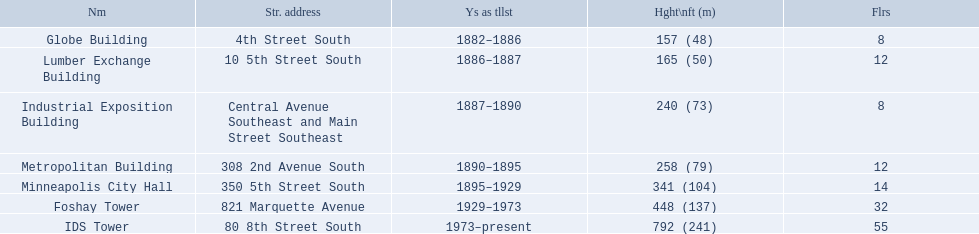How many floors does the globe building have? 8. Which building has 14 floors? Minneapolis City Hall. The lumber exchange building has the same number of floors as which building? Metropolitan Building. 